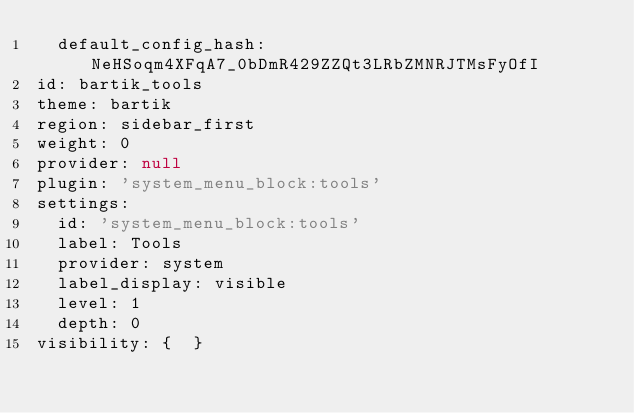<code> <loc_0><loc_0><loc_500><loc_500><_YAML_>  default_config_hash: NeHSoqm4XFqA7_0bDmR429ZZQt3LRbZMNRJTMsFyOfI
id: bartik_tools
theme: bartik
region: sidebar_first
weight: 0
provider: null
plugin: 'system_menu_block:tools'
settings:
  id: 'system_menu_block:tools'
  label: Tools
  provider: system
  label_display: visible
  level: 1
  depth: 0
visibility: {  }
</code> 